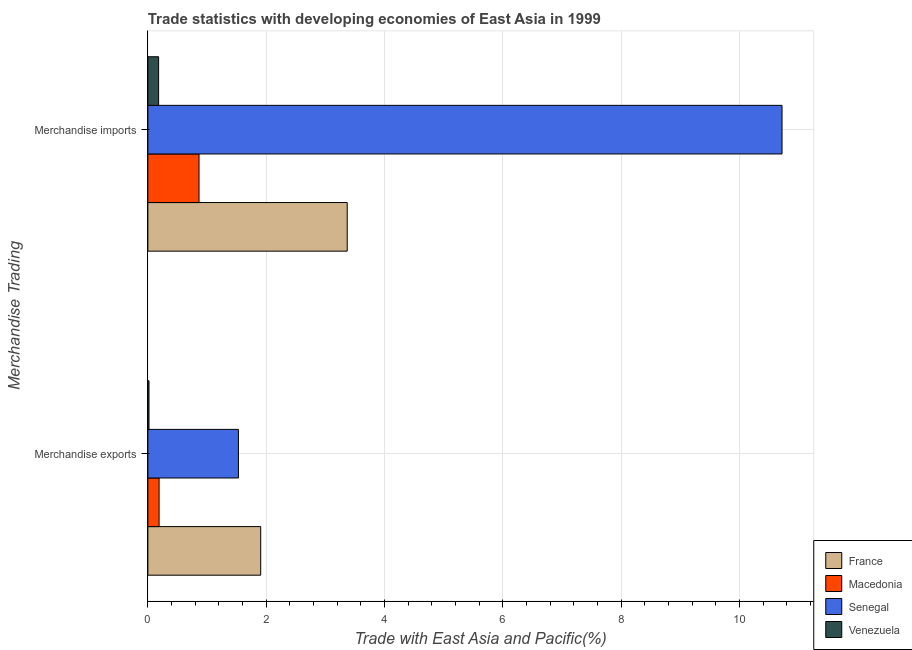How many different coloured bars are there?
Provide a succinct answer. 4. Are the number of bars on each tick of the Y-axis equal?
Your answer should be very brief. Yes. How many bars are there on the 2nd tick from the top?
Your answer should be very brief. 4. What is the merchandise exports in Senegal?
Make the answer very short. 1.53. Across all countries, what is the maximum merchandise exports?
Ensure brevity in your answer.  1.91. Across all countries, what is the minimum merchandise exports?
Your response must be concise. 0.02. In which country was the merchandise imports maximum?
Your answer should be compact. Senegal. In which country was the merchandise exports minimum?
Offer a very short reply. Venezuela. What is the total merchandise imports in the graph?
Provide a succinct answer. 15.13. What is the difference between the merchandise exports in Senegal and that in Macedonia?
Make the answer very short. 1.34. What is the difference between the merchandise imports in France and the merchandise exports in Macedonia?
Give a very brief answer. 3.18. What is the average merchandise imports per country?
Provide a succinct answer. 3.78. What is the difference between the merchandise imports and merchandise exports in Macedonia?
Provide a short and direct response. 0.68. What is the ratio of the merchandise imports in Venezuela to that in Senegal?
Your response must be concise. 0.02. What does the 2nd bar from the top in Merchandise exports represents?
Provide a short and direct response. Senegal. What does the 3rd bar from the bottom in Merchandise exports represents?
Make the answer very short. Senegal. How many bars are there?
Offer a very short reply. 8. What is the difference between two consecutive major ticks on the X-axis?
Your answer should be very brief. 2. Does the graph contain grids?
Your response must be concise. Yes. Where does the legend appear in the graph?
Provide a short and direct response. Bottom right. How many legend labels are there?
Offer a very short reply. 4. How are the legend labels stacked?
Provide a short and direct response. Vertical. What is the title of the graph?
Offer a very short reply. Trade statistics with developing economies of East Asia in 1999. Does "Lao PDR" appear as one of the legend labels in the graph?
Give a very brief answer. No. What is the label or title of the X-axis?
Make the answer very short. Trade with East Asia and Pacific(%). What is the label or title of the Y-axis?
Keep it short and to the point. Merchandise Trading. What is the Trade with East Asia and Pacific(%) of France in Merchandise exports?
Offer a very short reply. 1.91. What is the Trade with East Asia and Pacific(%) of Macedonia in Merchandise exports?
Provide a short and direct response. 0.19. What is the Trade with East Asia and Pacific(%) of Senegal in Merchandise exports?
Ensure brevity in your answer.  1.53. What is the Trade with East Asia and Pacific(%) of Venezuela in Merchandise exports?
Give a very brief answer. 0.02. What is the Trade with East Asia and Pacific(%) of France in Merchandise imports?
Ensure brevity in your answer.  3.37. What is the Trade with East Asia and Pacific(%) of Macedonia in Merchandise imports?
Your answer should be compact. 0.86. What is the Trade with East Asia and Pacific(%) of Senegal in Merchandise imports?
Your answer should be very brief. 10.72. What is the Trade with East Asia and Pacific(%) of Venezuela in Merchandise imports?
Offer a terse response. 0.18. Across all Merchandise Trading, what is the maximum Trade with East Asia and Pacific(%) of France?
Offer a terse response. 3.37. Across all Merchandise Trading, what is the maximum Trade with East Asia and Pacific(%) in Macedonia?
Your answer should be compact. 0.86. Across all Merchandise Trading, what is the maximum Trade with East Asia and Pacific(%) of Senegal?
Your answer should be compact. 10.72. Across all Merchandise Trading, what is the maximum Trade with East Asia and Pacific(%) of Venezuela?
Provide a short and direct response. 0.18. Across all Merchandise Trading, what is the minimum Trade with East Asia and Pacific(%) in France?
Provide a short and direct response. 1.91. Across all Merchandise Trading, what is the minimum Trade with East Asia and Pacific(%) of Macedonia?
Offer a terse response. 0.19. Across all Merchandise Trading, what is the minimum Trade with East Asia and Pacific(%) of Senegal?
Offer a terse response. 1.53. Across all Merchandise Trading, what is the minimum Trade with East Asia and Pacific(%) in Venezuela?
Ensure brevity in your answer.  0.02. What is the total Trade with East Asia and Pacific(%) in France in the graph?
Provide a short and direct response. 5.28. What is the total Trade with East Asia and Pacific(%) of Macedonia in the graph?
Provide a succinct answer. 1.05. What is the total Trade with East Asia and Pacific(%) in Senegal in the graph?
Provide a short and direct response. 12.25. What is the total Trade with East Asia and Pacific(%) in Venezuela in the graph?
Give a very brief answer. 0.2. What is the difference between the Trade with East Asia and Pacific(%) in France in Merchandise exports and that in Merchandise imports?
Your response must be concise. -1.46. What is the difference between the Trade with East Asia and Pacific(%) in Macedonia in Merchandise exports and that in Merchandise imports?
Make the answer very short. -0.68. What is the difference between the Trade with East Asia and Pacific(%) of Senegal in Merchandise exports and that in Merchandise imports?
Provide a short and direct response. -9.19. What is the difference between the Trade with East Asia and Pacific(%) in Venezuela in Merchandise exports and that in Merchandise imports?
Offer a very short reply. -0.16. What is the difference between the Trade with East Asia and Pacific(%) of France in Merchandise exports and the Trade with East Asia and Pacific(%) of Macedonia in Merchandise imports?
Your answer should be compact. 1.04. What is the difference between the Trade with East Asia and Pacific(%) in France in Merchandise exports and the Trade with East Asia and Pacific(%) in Senegal in Merchandise imports?
Make the answer very short. -8.81. What is the difference between the Trade with East Asia and Pacific(%) in France in Merchandise exports and the Trade with East Asia and Pacific(%) in Venezuela in Merchandise imports?
Ensure brevity in your answer.  1.73. What is the difference between the Trade with East Asia and Pacific(%) in Macedonia in Merchandise exports and the Trade with East Asia and Pacific(%) in Senegal in Merchandise imports?
Offer a terse response. -10.53. What is the difference between the Trade with East Asia and Pacific(%) in Macedonia in Merchandise exports and the Trade with East Asia and Pacific(%) in Venezuela in Merchandise imports?
Offer a terse response. 0.01. What is the difference between the Trade with East Asia and Pacific(%) in Senegal in Merchandise exports and the Trade with East Asia and Pacific(%) in Venezuela in Merchandise imports?
Keep it short and to the point. 1.35. What is the average Trade with East Asia and Pacific(%) in France per Merchandise Trading?
Your answer should be compact. 2.64. What is the average Trade with East Asia and Pacific(%) in Macedonia per Merchandise Trading?
Make the answer very short. 0.53. What is the average Trade with East Asia and Pacific(%) of Senegal per Merchandise Trading?
Make the answer very short. 6.12. What is the average Trade with East Asia and Pacific(%) in Venezuela per Merchandise Trading?
Give a very brief answer. 0.1. What is the difference between the Trade with East Asia and Pacific(%) of France and Trade with East Asia and Pacific(%) of Macedonia in Merchandise exports?
Offer a terse response. 1.72. What is the difference between the Trade with East Asia and Pacific(%) of France and Trade with East Asia and Pacific(%) of Senegal in Merchandise exports?
Offer a very short reply. 0.38. What is the difference between the Trade with East Asia and Pacific(%) of France and Trade with East Asia and Pacific(%) of Venezuela in Merchandise exports?
Provide a short and direct response. 1.89. What is the difference between the Trade with East Asia and Pacific(%) in Macedonia and Trade with East Asia and Pacific(%) in Senegal in Merchandise exports?
Your answer should be very brief. -1.34. What is the difference between the Trade with East Asia and Pacific(%) of Macedonia and Trade with East Asia and Pacific(%) of Venezuela in Merchandise exports?
Provide a short and direct response. 0.17. What is the difference between the Trade with East Asia and Pacific(%) in Senegal and Trade with East Asia and Pacific(%) in Venezuela in Merchandise exports?
Your answer should be very brief. 1.51. What is the difference between the Trade with East Asia and Pacific(%) of France and Trade with East Asia and Pacific(%) of Macedonia in Merchandise imports?
Provide a succinct answer. 2.5. What is the difference between the Trade with East Asia and Pacific(%) in France and Trade with East Asia and Pacific(%) in Senegal in Merchandise imports?
Provide a short and direct response. -7.35. What is the difference between the Trade with East Asia and Pacific(%) in France and Trade with East Asia and Pacific(%) in Venezuela in Merchandise imports?
Offer a terse response. 3.19. What is the difference between the Trade with East Asia and Pacific(%) of Macedonia and Trade with East Asia and Pacific(%) of Senegal in Merchandise imports?
Provide a succinct answer. -9.85. What is the difference between the Trade with East Asia and Pacific(%) of Macedonia and Trade with East Asia and Pacific(%) of Venezuela in Merchandise imports?
Ensure brevity in your answer.  0.68. What is the difference between the Trade with East Asia and Pacific(%) in Senegal and Trade with East Asia and Pacific(%) in Venezuela in Merchandise imports?
Your answer should be compact. 10.54. What is the ratio of the Trade with East Asia and Pacific(%) in France in Merchandise exports to that in Merchandise imports?
Your response must be concise. 0.57. What is the ratio of the Trade with East Asia and Pacific(%) in Macedonia in Merchandise exports to that in Merchandise imports?
Ensure brevity in your answer.  0.22. What is the ratio of the Trade with East Asia and Pacific(%) of Senegal in Merchandise exports to that in Merchandise imports?
Provide a short and direct response. 0.14. What is the ratio of the Trade with East Asia and Pacific(%) of Venezuela in Merchandise exports to that in Merchandise imports?
Your answer should be very brief. 0.11. What is the difference between the highest and the second highest Trade with East Asia and Pacific(%) of France?
Your answer should be very brief. 1.46. What is the difference between the highest and the second highest Trade with East Asia and Pacific(%) in Macedonia?
Your answer should be compact. 0.68. What is the difference between the highest and the second highest Trade with East Asia and Pacific(%) of Senegal?
Give a very brief answer. 9.19. What is the difference between the highest and the second highest Trade with East Asia and Pacific(%) of Venezuela?
Make the answer very short. 0.16. What is the difference between the highest and the lowest Trade with East Asia and Pacific(%) in France?
Keep it short and to the point. 1.46. What is the difference between the highest and the lowest Trade with East Asia and Pacific(%) of Macedonia?
Keep it short and to the point. 0.68. What is the difference between the highest and the lowest Trade with East Asia and Pacific(%) in Senegal?
Ensure brevity in your answer.  9.19. What is the difference between the highest and the lowest Trade with East Asia and Pacific(%) of Venezuela?
Your response must be concise. 0.16. 